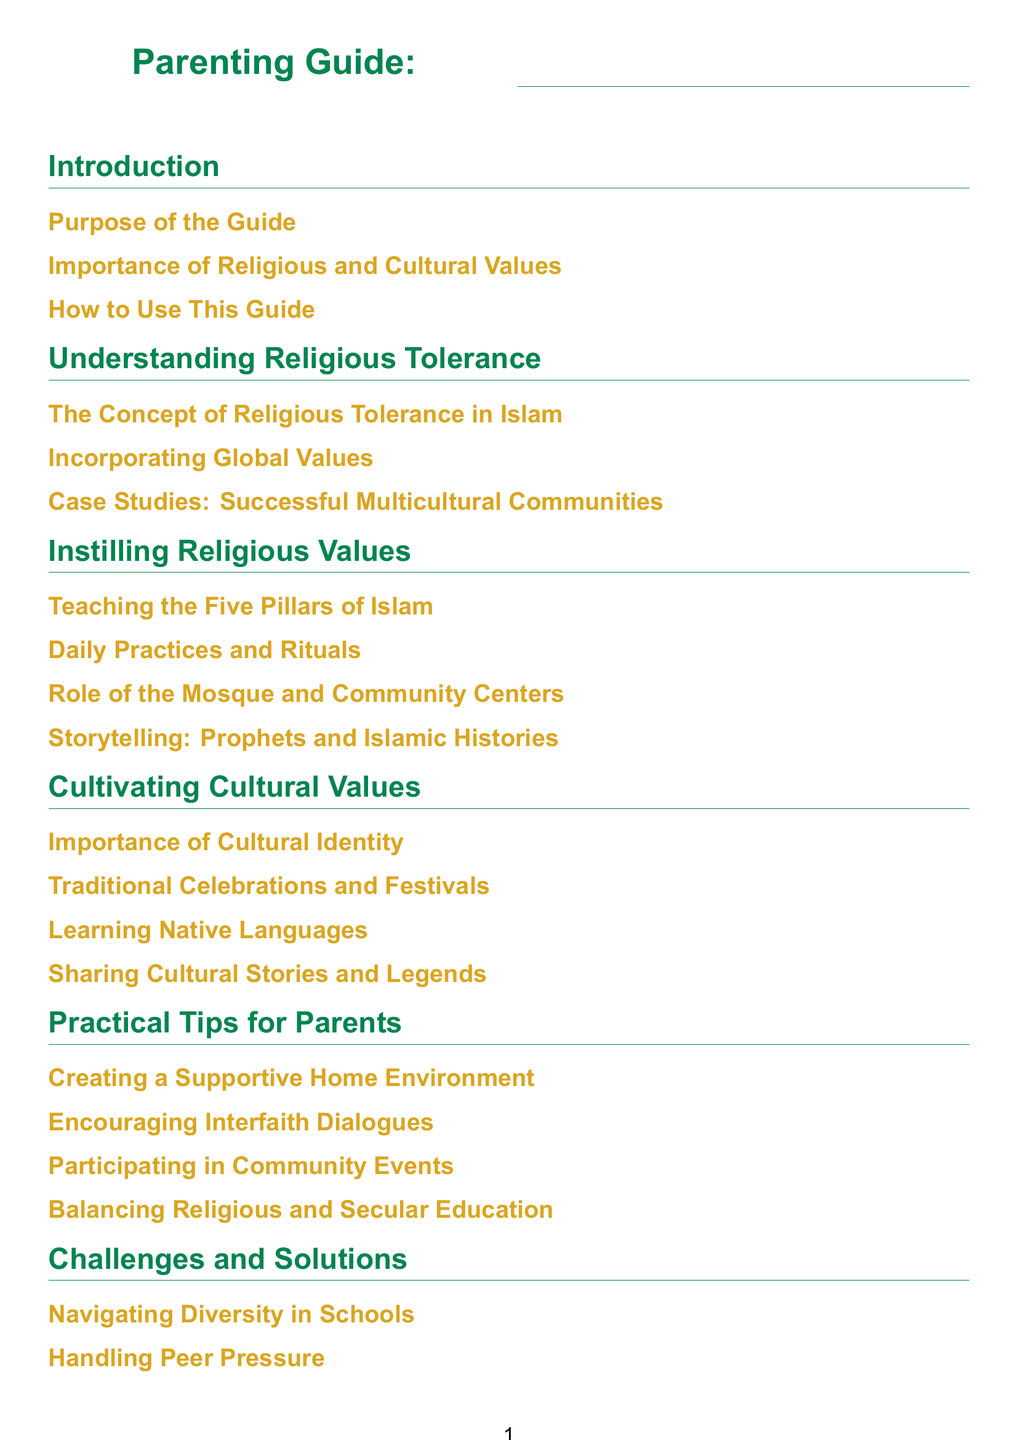What is the purpose of the guide? The purpose of the guide is outlined in the introduction section.
Answer: To provide practical tips for instilling religious and cultural values How many sections are in the document? The document is structured into eight main sections as shown in the table of contents.
Answer: Eight sections What are the five pillars of Islam? The teaching of the five pillars is mentioned in the section on instilling religious values.
Answer: Teaching the Five Pillars of Islam What type of literature is recommended for children? The resources for further reading include different categories, one being specifically for children.
Answer: Children's Literature What is highlighted under the challenges and solutions section? The challenges and solutions section contains specific topics regarding challenges parents face.
Answer: Navigating Diversity in Schools What does the section on practical tips focus on? The section emphasizes various strategies for parents to support their children.
Answer: Creating a Supportive Home Environment What is the significance of cultural identity? The importance of cultural identity is discussed in the section on cultivating cultural values.
Answer: Importance of Cultural Identity What is included in the conclusion of the guide? The conclusion synthesizes the main ideas presented throughout the guide.
Answer: Summary of Key Points 